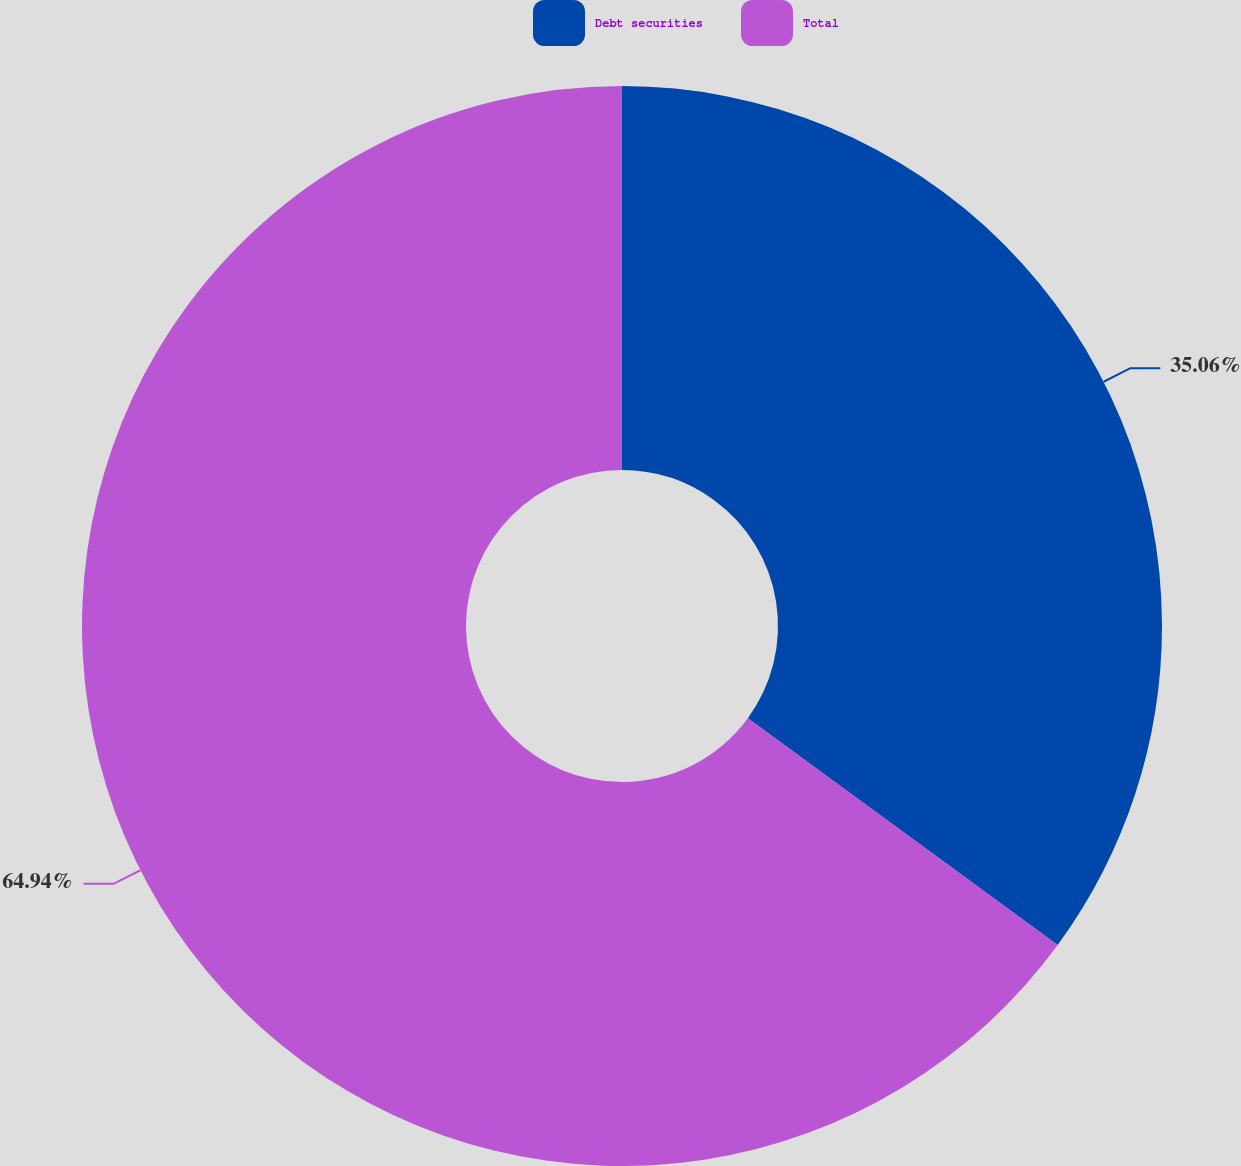<chart> <loc_0><loc_0><loc_500><loc_500><pie_chart><fcel>Debt securities<fcel>Total<nl><fcel>35.06%<fcel>64.94%<nl></chart> 